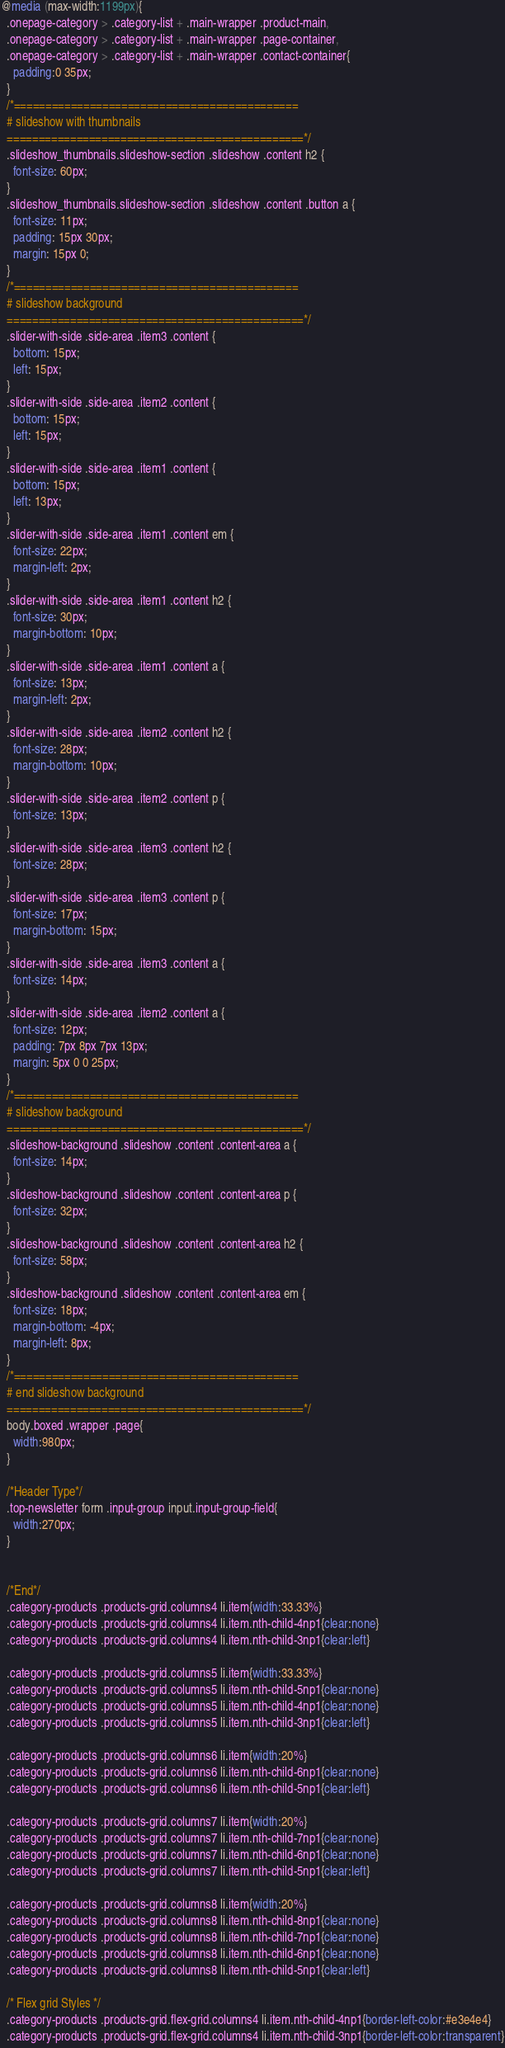<code> <loc_0><loc_0><loc_500><loc_500><_CSS_>@media (max-width:1199px){
  .onepage-category > .category-list + .main-wrapper .product-main,
  .onepage-category > .category-list + .main-wrapper .page-container,
  .onepage-category > .category-list + .main-wrapper .contact-container{
    padding:0 35px;
  } 
  /*=============================================
  # slideshow with thumbnails
  ===============================================*/
  .slideshow_thumbnails.slideshow-section .slideshow .content h2 {
    font-size: 60px;
  }
  .slideshow_thumbnails.slideshow-section .slideshow .content .button a {
    font-size: 11px;
    padding: 15px 30px;
    margin: 15px 0;
  }
  /*=============================================
  # slideshow background
  ===============================================*/
  .slider-with-side .side-area .item3 .content {
    bottom: 15px;
    left: 15px;
  }
  .slider-with-side .side-area .item2 .content {
    bottom: 15px;
    left: 15px;
  }
  .slider-with-side .side-area .item1 .content {
    bottom: 15px;
    left: 13px;
  }
  .slider-with-side .side-area .item1 .content em {
    font-size: 22px;
    margin-left: 2px;
  }
  .slider-with-side .side-area .item1 .content h2 {
    font-size: 30px;
    margin-bottom: 10px;
  }
  .slider-with-side .side-area .item1 .content a {
    font-size: 13px;
    margin-left: 2px;
  }
  .slider-with-side .side-area .item2 .content h2 {
    font-size: 28px;
    margin-bottom: 10px;
  }
  .slider-with-side .side-area .item2 .content p {
    font-size: 13px;
  }
  .slider-with-side .side-area .item3 .content h2 {
    font-size: 28px;
  }
  .slider-with-side .side-area .item3 .content p {
    font-size: 17px;
    margin-bottom: 15px;
  }
  .slider-with-side .side-area .item3 .content a {
    font-size: 14px;
  }
  .slider-with-side .side-area .item2 .content a {
    font-size: 12px;
    padding: 7px 8px 7px 13px;
    margin: 5px 0 0 25px;
  }
  /*=============================================
  # slideshow background
  ===============================================*/
  .slideshow-background .slideshow .content .content-area a {
    font-size: 14px;
  }
  .slideshow-background .slideshow .content .content-area p {
    font-size: 32px;
  }
  .slideshow-background .slideshow .content .content-area h2 {
    font-size: 58px;
  }
  .slideshow-background .slideshow .content .content-area em {
    font-size: 18px;
    margin-bottom: -4px;
    margin-left: 8px;
  }
  /*=============================================
  # end slideshow background
  ===============================================*/
  body.boxed .wrapper .page{
  	width:980px;
  } 
  
  /*Header Type*/
  .top-newsletter form .input-group input.input-group-field{
    width:270px;
  }
  
  
  /*End*/
  .category-products .products-grid.columns4 li.item{width:33.33%}
  .category-products .products-grid.columns4 li.item.nth-child-4np1{clear:none}
  .category-products .products-grid.columns4 li.item.nth-child-3np1{clear:left}

  .category-products .products-grid.columns5 li.item{width:33.33%}
  .category-products .products-grid.columns5 li.item.nth-child-5np1{clear:none}
  .category-products .products-grid.columns5 li.item.nth-child-4np1{clear:none}
  .category-products .products-grid.columns5 li.item.nth-child-3np1{clear:left}

  .category-products .products-grid.columns6 li.item{width:20%}
  .category-products .products-grid.columns6 li.item.nth-child-6np1{clear:none}
  .category-products .products-grid.columns6 li.item.nth-child-5np1{clear:left}

  .category-products .products-grid.columns7 li.item{width:20%}
  .category-products .products-grid.columns7 li.item.nth-child-7np1{clear:none}
  .category-products .products-grid.columns7 li.item.nth-child-6np1{clear:none}
  .category-products .products-grid.columns7 li.item.nth-child-5np1{clear:left}

  .category-products .products-grid.columns8 li.item{width:20%}
  .category-products .products-grid.columns8 li.item.nth-child-8np1{clear:none}
  .category-products .products-grid.columns8 li.item.nth-child-7np1{clear:none}
  .category-products .products-grid.columns8 li.item.nth-child-6np1{clear:none}
  .category-products .products-grid.columns8 li.item.nth-child-5np1{clear:left}

  /* Flex grid Styles */
  .category-products .products-grid.flex-grid.columns4 li.item.nth-child-4np1{border-left-color:#e3e4e4}
  .category-products .products-grid.flex-grid.columns4 li.item.nth-child-3np1{border-left-color:transparent}
</code> 